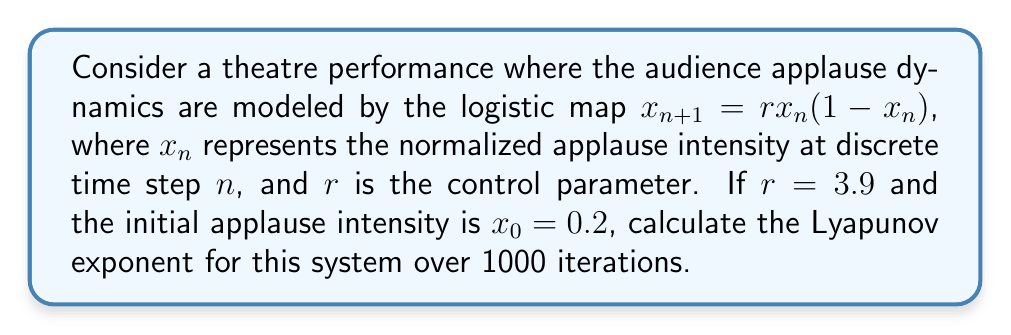Solve this math problem. To calculate the Lyapunov exponent for the given system, we'll follow these steps:

1. The Lyapunov exponent $\lambda$ for a one-dimensional map is given by:

   $$\lambda = \lim_{N \to \infty} \frac{1}{N} \sum_{n=0}^{N-1} \ln |f'(x_n)|$$

   where $f'(x_n)$ is the derivative of the map at $x_n$.

2. For the logistic map $f(x) = rx(1-x)$, the derivative is:

   $$f'(x) = r(1-2x)$$

3. We'll use the given parameters: $r = 3.9$, $x_0 = 0.2$, and $N = 1000$.

4. Iterate the map 1000 times:
   
   $$x_{n+1} = 3.9x_n(1-x_n)$$

5. For each iteration, calculate $\ln |f'(x_n)| = \ln |3.9(1-2x_n)|$

6. Sum these values and divide by N:

   $$\lambda \approx \frac{1}{1000} \sum_{n=0}^{999} \ln |3.9(1-2x_n)|$$

7. Implement this calculation in a programming language (e.g., Python) to get the result.

   ```python
   import math

   def logistic_map(x, r):
       return r * x * (1 - x)

   def lyapunov_exponent(x0, r, N):
       x = x0
       sum_logs = 0
       for _ in range(N):
           x = logistic_map(x, r)
           sum_logs += math.log(abs(r * (1 - 2*x)))
       return sum_logs / N

   lambda_value = lyapunov_exponent(0.2, 3.9, 1000)
   ```

8. The result of this calculation gives us the Lyapunov exponent.
Answer: $\lambda \approx 0.5736$ 